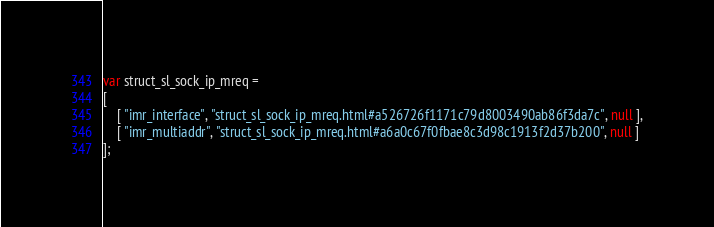<code> <loc_0><loc_0><loc_500><loc_500><_JavaScript_>var struct_sl_sock_ip_mreq =
[
    [ "imr_interface", "struct_sl_sock_ip_mreq.html#a526726f1171c79d8003490ab86f3da7c", null ],
    [ "imr_multiaddr", "struct_sl_sock_ip_mreq.html#a6a0c67f0fbae8c3d98c1913f2d37b200", null ]
];</code> 